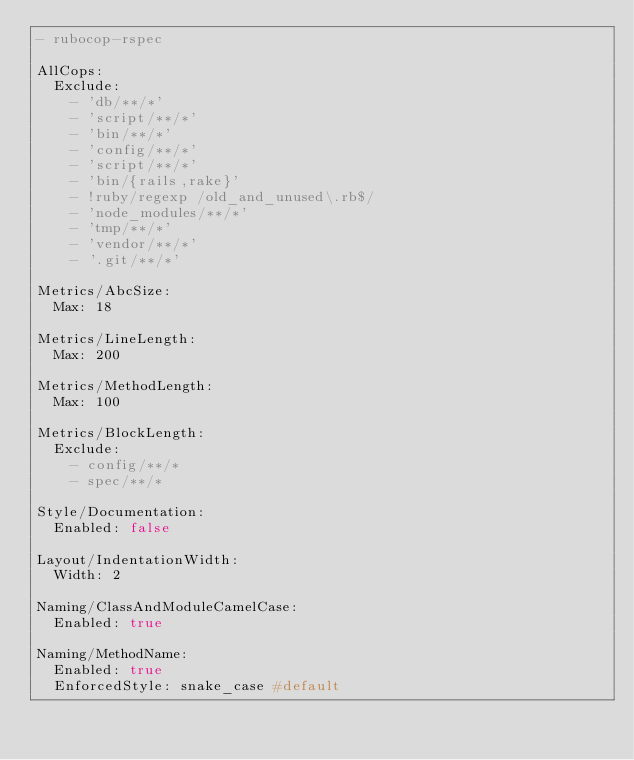<code> <loc_0><loc_0><loc_500><loc_500><_YAML_>- rubocop-rspec

AllCops:
  Exclude:
    - 'db/**/*'
    - 'script/**/*'
    - 'bin/**/*'
    - 'config/**/*'
    - 'script/**/*'
    - 'bin/{rails,rake}'
    - !ruby/regexp /old_and_unused\.rb$/
    - 'node_modules/**/*'
    - 'tmp/**/*'
    - 'vendor/**/*'
    - '.git/**/*'

Metrics/AbcSize:
  Max: 18
  
Metrics/LineLength:
  Max: 200

Metrics/MethodLength:
  Max: 100

Metrics/BlockLength:
  Exclude:
    - config/**/*
    - spec/**/*

Style/Documentation:
  Enabled: false

Layout/IndentationWidth:
  Width: 2

Naming/ClassAndModuleCamelCase:
  Enabled: true

Naming/MethodName:
  Enabled: true
  EnforcedStyle: snake_case #default</code> 